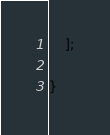Convert code to text. <code><loc_0><loc_0><loc_500><loc_500><_PHP_>	];

}
</code> 